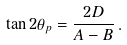Convert formula to latex. <formula><loc_0><loc_0><loc_500><loc_500>\tan 2 \theta _ { p } = \frac { 2 D } { A - B } \, .</formula> 